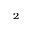<formula> <loc_0><loc_0><loc_500><loc_500>_ { 2 }</formula> 